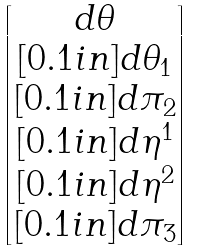<formula> <loc_0><loc_0><loc_500><loc_500>\begin{bmatrix} d \theta \\ [ 0 . 1 i n ] d \theta _ { 1 } \\ [ 0 . 1 i n ] d \pi _ { 2 } \\ [ 0 . 1 i n ] d \eta ^ { 1 } \\ [ 0 . 1 i n ] d \eta ^ { 2 } \\ [ 0 . 1 i n ] d \pi _ { 3 } \end{bmatrix}</formula> 